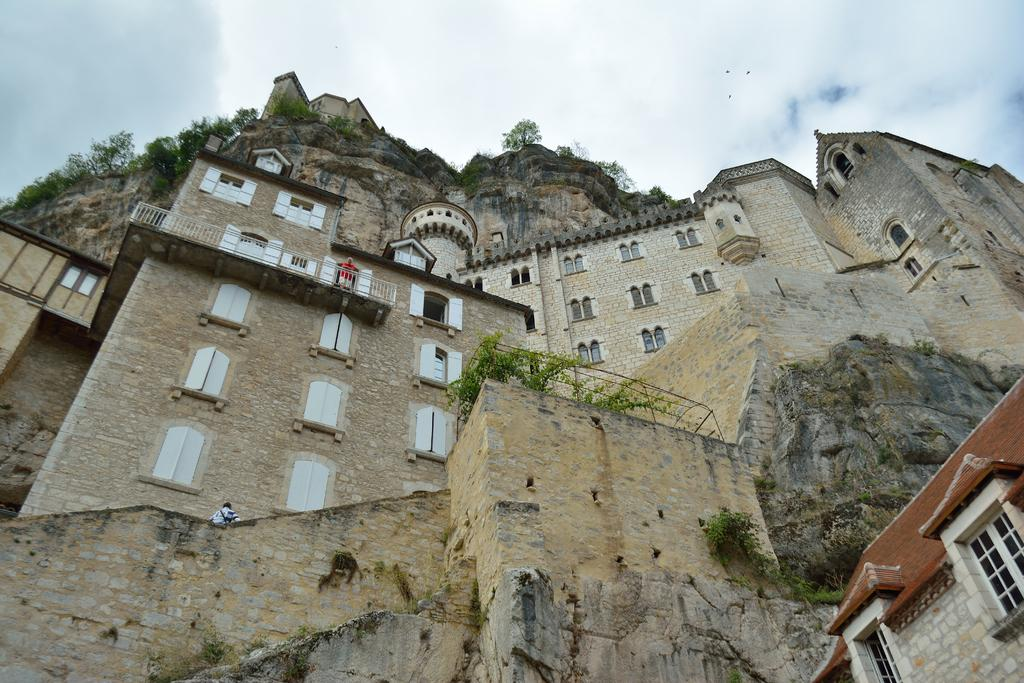What structures are located in the foreground of the image? There are buildings in the foreground of the image. What type of natural feature is present in the foreground of the image? There is a hill in the foreground of the image. What type of vegetation is visible in the foreground of the image? There are trees in the foreground of the image. What part of the natural environment is visible in the foreground of the image? The sky is visible in the foreground of the image. What can be seen in the sky in the foreground of the image? There are clouds visible in the foreground of the image. Where is the harbor located in the image? There is no harbor present in the image. What type of wall is visible in the image? There is no wall present in the image. How many girls are visible in the image? There are no girls present in the image. 